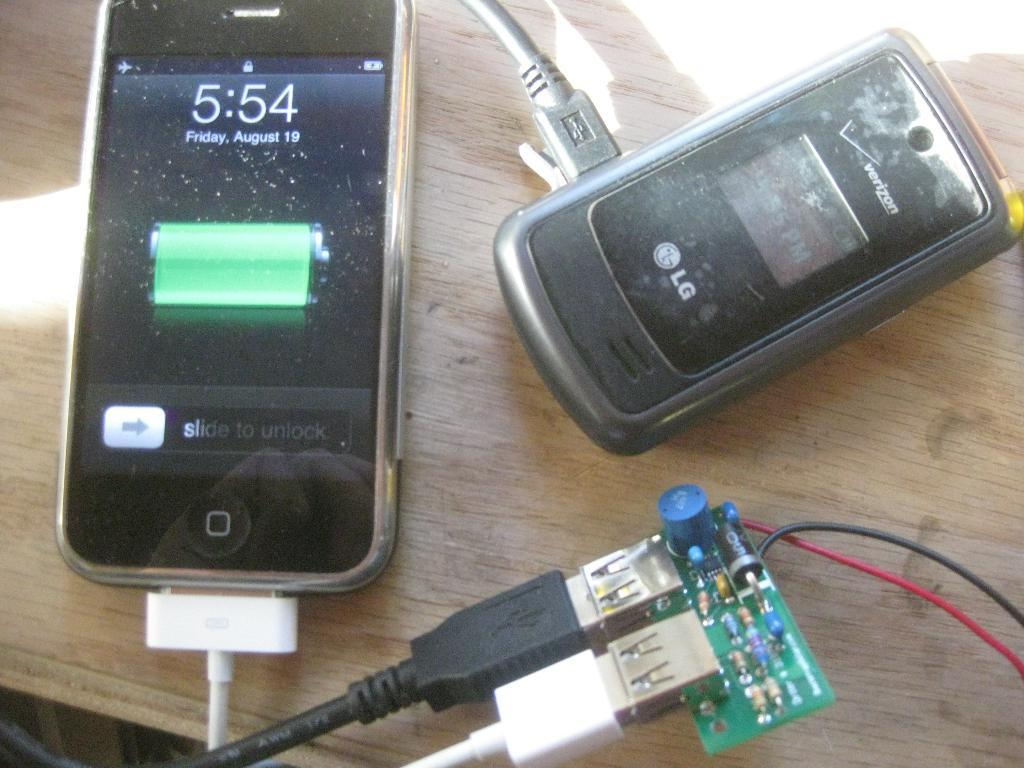How many mobiles can be seen in the image? There are two mobiles in the image. What is the condition of one of the mobiles in the image? One of the mobiles is connected to a USB cable, which suggests it is likely charging. What type of pancake is being served on the neck of the bear in the image? There is no pancake or bear present in the image; it features two mobiles, one of which is connected to a USB cable. 